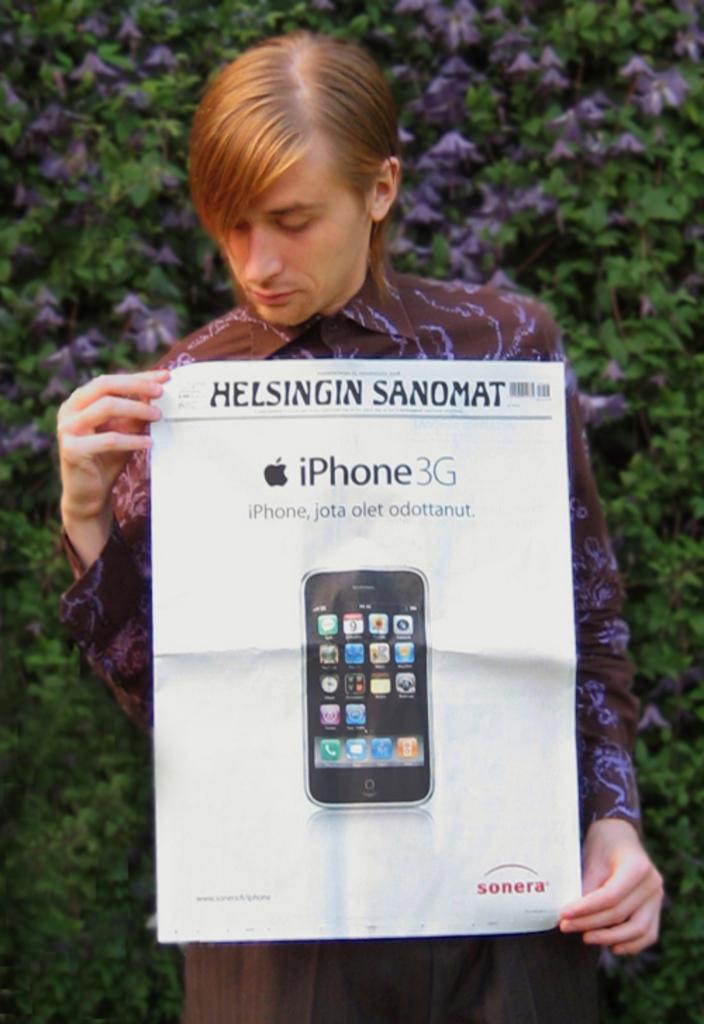What is the man in the image doing? The man is standing in the image and holding a poster. What can be seen in the background of the image? There are plants visible in the background of the image. What type of yam is the man using to control the plants in the image? There is no yam present in the image, and the man is not controlling any plants. 